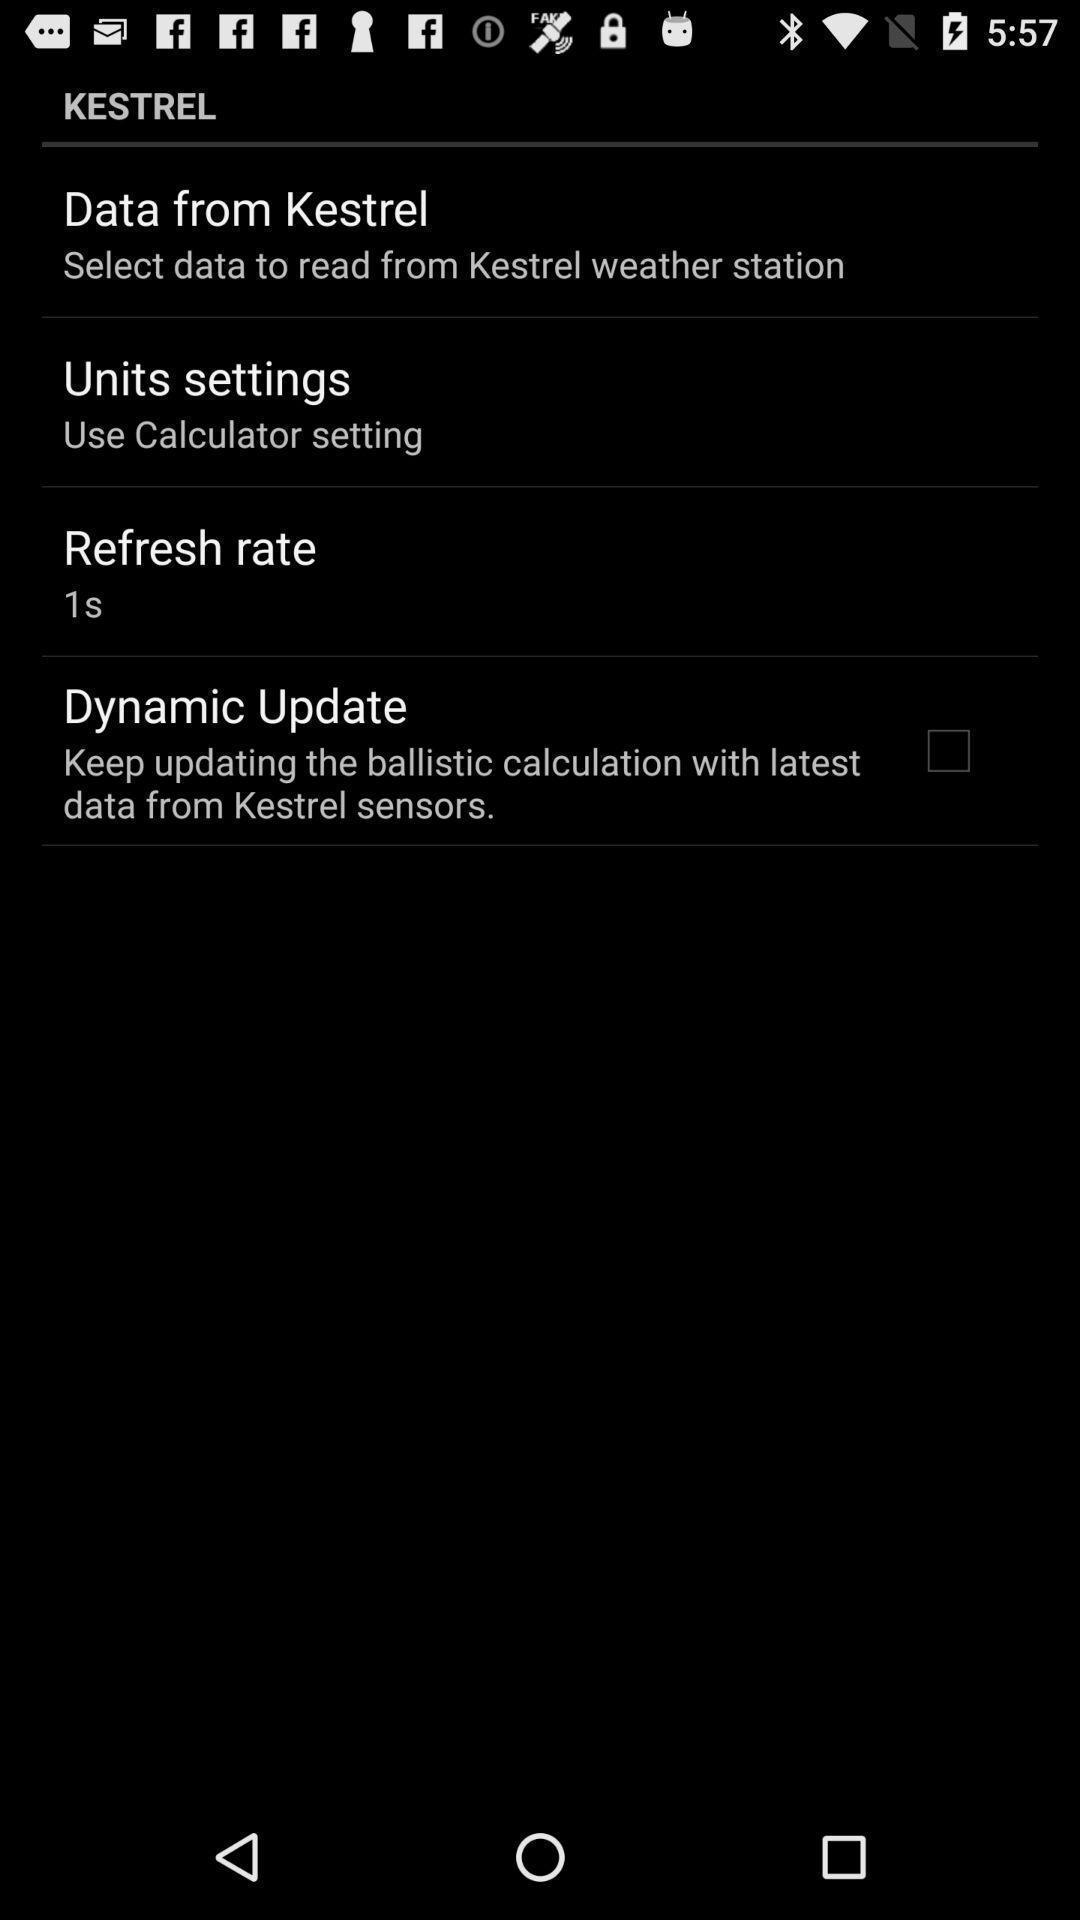Describe the key features of this screenshot. Screen displaying options. 